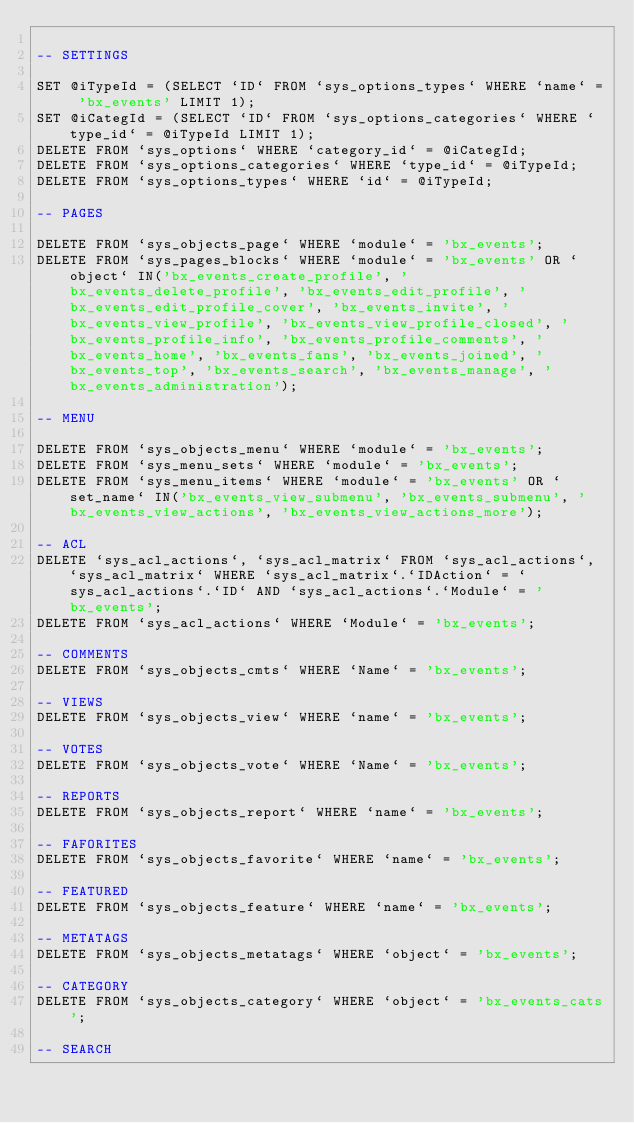<code> <loc_0><loc_0><loc_500><loc_500><_SQL_>
-- SETTINGS

SET @iTypeId = (SELECT `ID` FROM `sys_options_types` WHERE `name` = 'bx_events' LIMIT 1);
SET @iCategId = (SELECT `ID` FROM `sys_options_categories` WHERE `type_id` = @iTypeId LIMIT 1);
DELETE FROM `sys_options` WHERE `category_id` = @iCategId;
DELETE FROM `sys_options_categories` WHERE `type_id` = @iTypeId;
DELETE FROM `sys_options_types` WHERE `id` = @iTypeId;

-- PAGES

DELETE FROM `sys_objects_page` WHERE `module` = 'bx_events';
DELETE FROM `sys_pages_blocks` WHERE `module` = 'bx_events' OR `object` IN('bx_events_create_profile', 'bx_events_delete_profile', 'bx_events_edit_profile', 'bx_events_edit_profile_cover', 'bx_events_invite', 'bx_events_view_profile', 'bx_events_view_profile_closed', 'bx_events_profile_info', 'bx_events_profile_comments', 'bx_events_home', 'bx_events_fans', 'bx_events_joined', 'bx_events_top', 'bx_events_search', 'bx_events_manage', 'bx_events_administration');

-- MENU

DELETE FROM `sys_objects_menu` WHERE `module` = 'bx_events';
DELETE FROM `sys_menu_sets` WHERE `module` = 'bx_events';
DELETE FROM `sys_menu_items` WHERE `module` = 'bx_events' OR `set_name` IN('bx_events_view_submenu', 'bx_events_submenu', 'bx_events_view_actions', 'bx_events_view_actions_more');

-- ACL
DELETE `sys_acl_actions`, `sys_acl_matrix` FROM `sys_acl_actions`, `sys_acl_matrix` WHERE `sys_acl_matrix`.`IDAction` = `sys_acl_actions`.`ID` AND `sys_acl_actions`.`Module` = 'bx_events';
DELETE FROM `sys_acl_actions` WHERE `Module` = 'bx_events';

-- COMMENTS
DELETE FROM `sys_objects_cmts` WHERE `Name` = 'bx_events';

-- VIEWS
DELETE FROM `sys_objects_view` WHERE `name` = 'bx_events';

-- VOTES
DELETE FROM `sys_objects_vote` WHERE `Name` = 'bx_events';

-- REPORTS
DELETE FROM `sys_objects_report` WHERE `name` = 'bx_events';

-- FAFORITES
DELETE FROM `sys_objects_favorite` WHERE `name` = 'bx_events';

-- FEATURED
DELETE FROM `sys_objects_feature` WHERE `name` = 'bx_events';

-- METATAGS
DELETE FROM `sys_objects_metatags` WHERE `object` = 'bx_events';

-- CATEGORY
DELETE FROM `sys_objects_category` WHERE `object` = 'bx_events_cats';

-- SEARCH</code> 